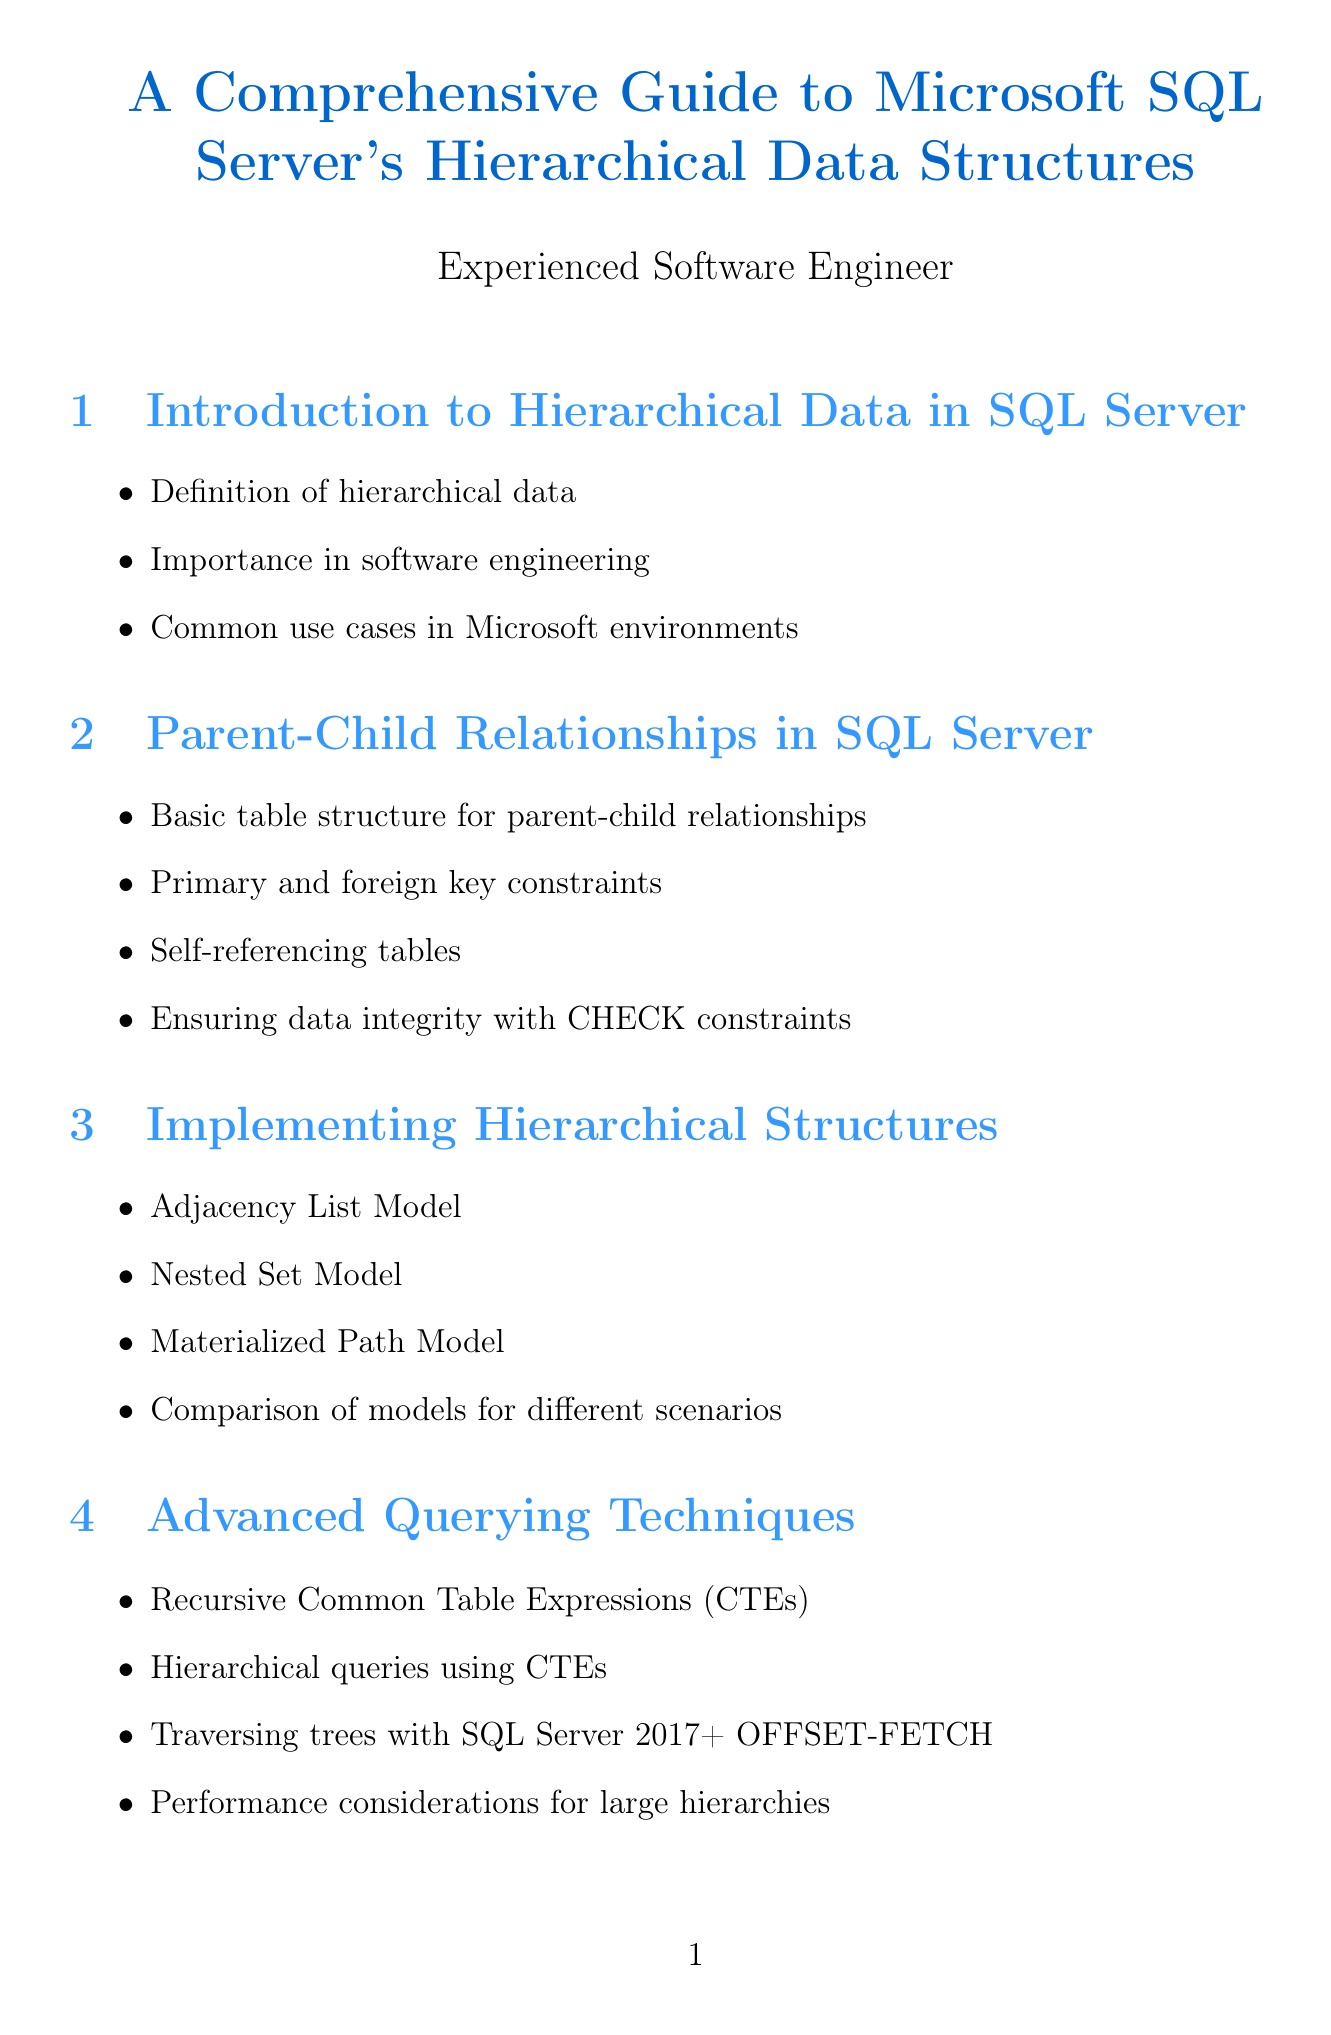What is the title of the document? The title is clearly stated at the beginning of the document.
Answer: A Comprehensive Guide to Microsoft SQL Server's Hierarchical Data Structures What SQL type is used for hierarchical structures? The document provides specific information about data types related to hierarchical structures.
Answer: hierarchyid What is the focus of the first section? The first section outlines general concepts related to hierarchical data in SQL Server.
Answer: Introduction to Hierarchical Data in SQL Server What technique is discussed for traversing hierarchy? This is found in the advanced querying techniques section, detailed with a method used from SQL Server 2017 onwards.
Answer: OFFSET-FETCH What was the result of optimizing Contoso Retail's product catalog? The case study mentions specific improvements highlighted as results of implementation strategies.
Answer: 50% improvement in query performance What challenge did Fabrikam face? The document details challenges faced by Fabrikam, particularly regarding its workforce structure.
Answer: Representing a multinational corporate structure What is a benefit of using a materialized path in hierarchical data? The document discusses various models and their advantages; this is inferred from the comparison section.
Answer: Simplified category management What is a key consideration when maintaining parent-child data? The document includes best practices, emphasizing the need to maintain quality in data management.
Answer: Maintaining data consistency during updates What is the primary purpose of using Recursive Common Table Expressions? The document addresses this querying method specifically for hierarchical queries in SQL Server.
Answer: Hierarchical queries using CTEs 